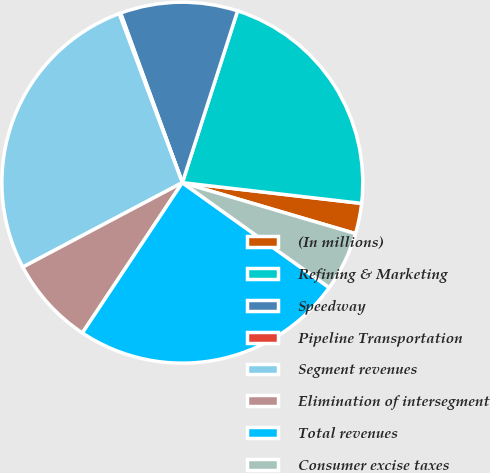Convert chart. <chart><loc_0><loc_0><loc_500><loc_500><pie_chart><fcel>(In millions)<fcel>Refining & Marketing<fcel>Speedway<fcel>Pipeline Transportation<fcel>Segment revenues<fcel>Elimination of intersegment<fcel>Total revenues<fcel>Consumer excise taxes<nl><fcel>2.72%<fcel>21.88%<fcel>10.51%<fcel>0.13%<fcel>27.06%<fcel>7.91%<fcel>24.47%<fcel>5.32%<nl></chart> 